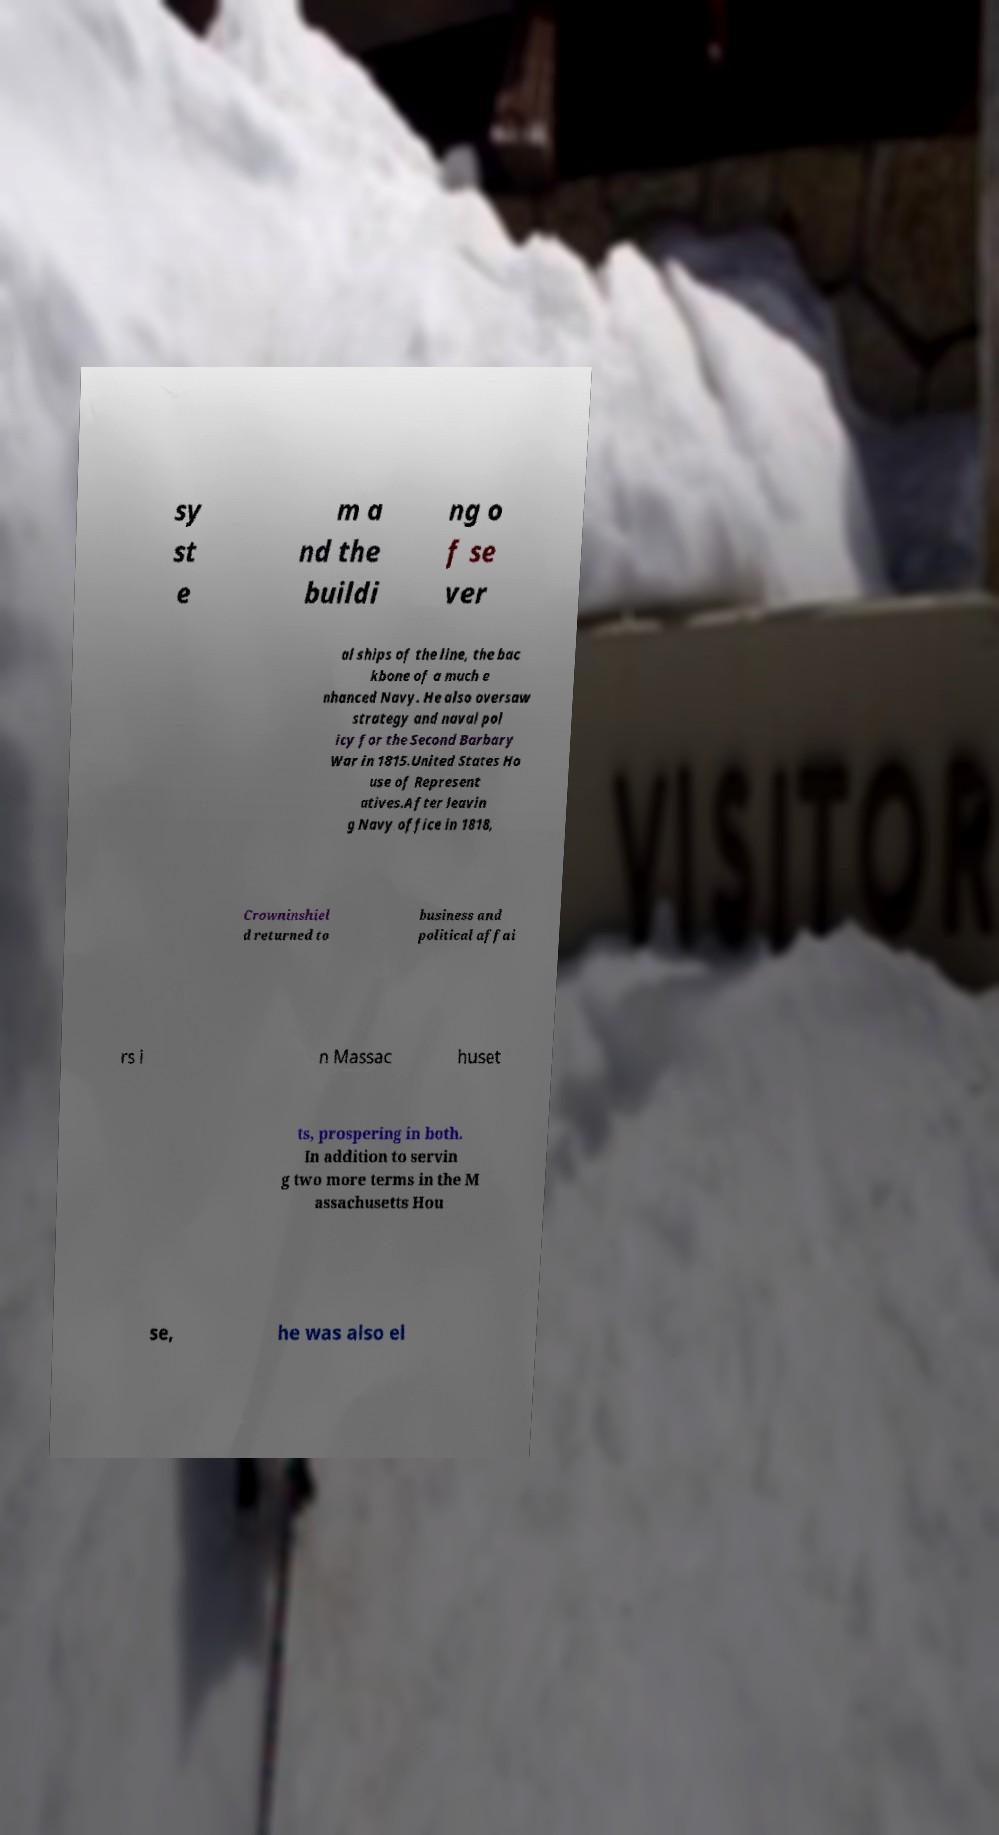Could you extract and type out the text from this image? sy st e m a nd the buildi ng o f se ver al ships of the line, the bac kbone of a much e nhanced Navy. He also oversaw strategy and naval pol icy for the Second Barbary War in 1815.United States Ho use of Represent atives.After leavin g Navy office in 1818, Crowninshiel d returned to business and political affai rs i n Massac huset ts, prospering in both. In addition to servin g two more terms in the M assachusetts Hou se, he was also el 